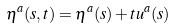Convert formula to latex. <formula><loc_0><loc_0><loc_500><loc_500>\eta ^ { a } ( s , t ) = \eta ^ { a } ( s ) + t u ^ { a } ( s )</formula> 